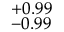<formula> <loc_0><loc_0><loc_500><loc_500>_ { - 0 . 9 9 } ^ { + 0 . 9 9 }</formula> 